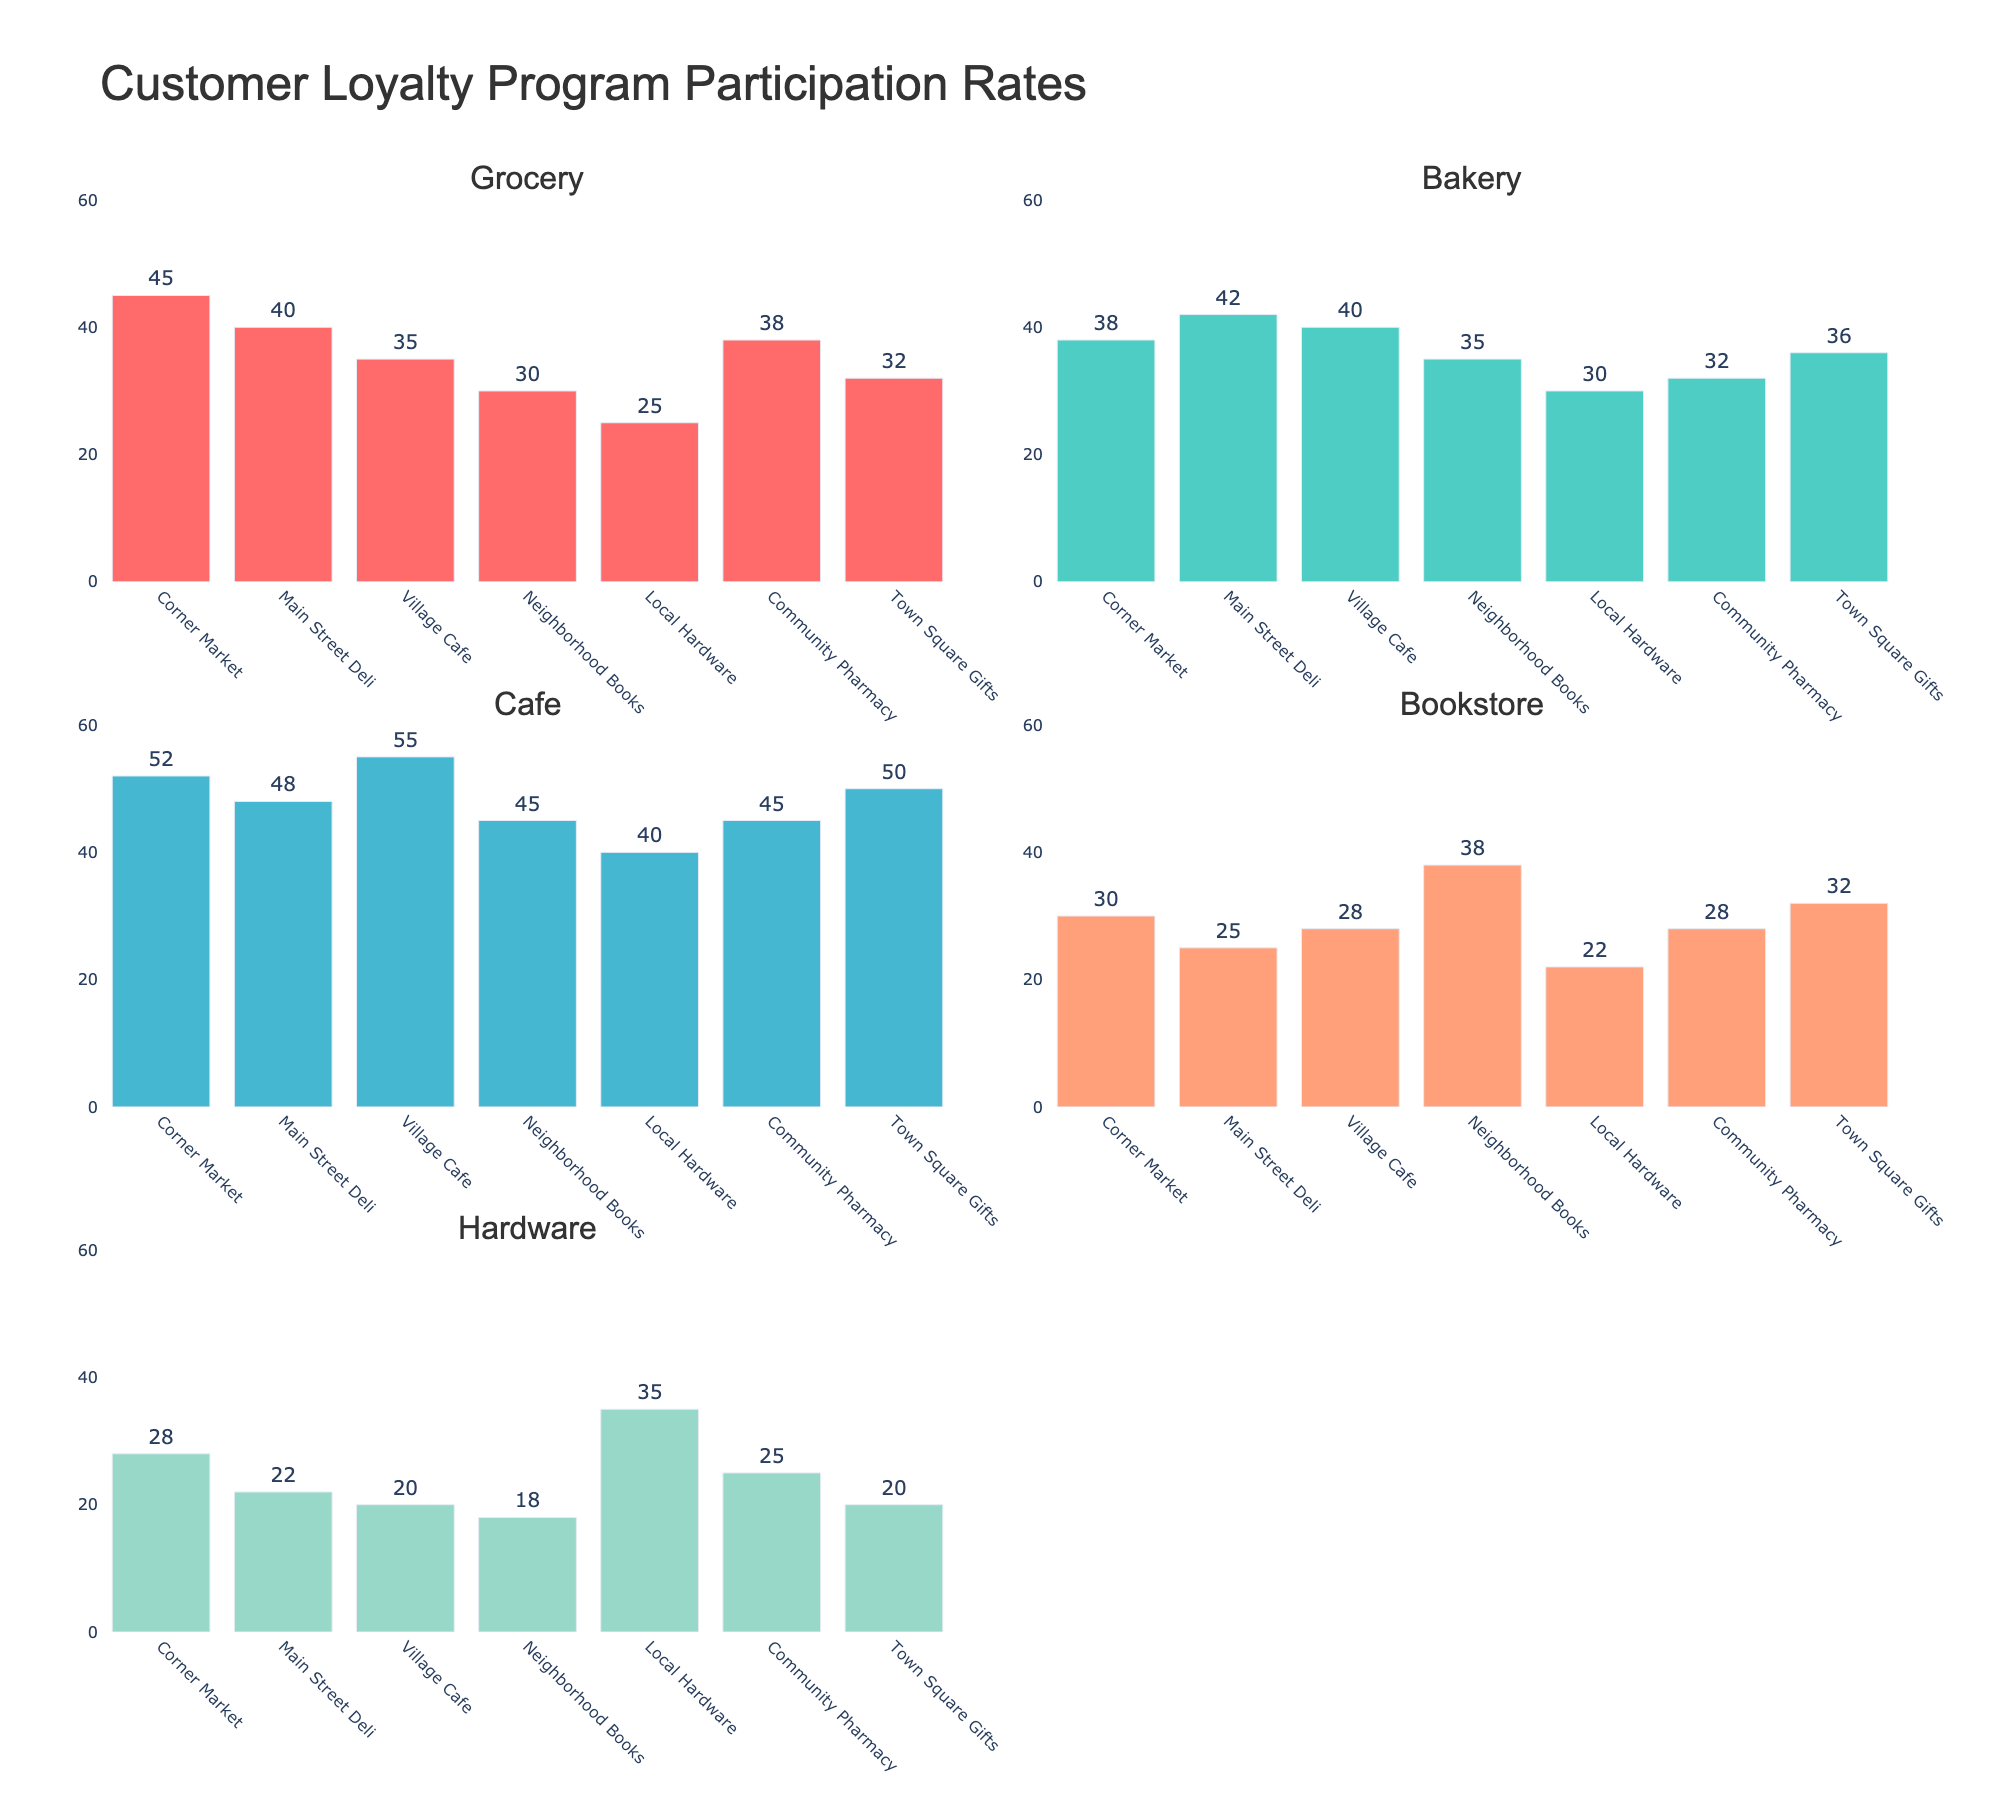What's the title of the figure? The title is displayed at the top center of the figure in a larger font size.
Answer: Customer Loyalty Program Participation Rates How many shop categories are compared in the figure? By counting the number of subplot titles, we can see there are 5 categories listed: Grocery, Bakery, Cafe, Bookstore, and Hardware.
Answer: 5 Which shop has the highest participation rate in the Cafe category? In the subplot for Cafe, the highest bar represents the Village Cafe, with a rate of 55%.
Answer: Village Cafe What is the participation rate for Main Street Deli in the Bakery category? Locate the bar corresponding to Main Street Deli in the Bakery subplot. The label shows a rate of 42%.
Answer: 42% Compare the Grocery participation rates of Corner Market and Local Hardware. Which is higher, and by how much? Corner Market has 45%, while Local Hardware has 25% in the Grocery category. Subtracting these gives the difference.
Answer: Corner Market is higher by 20% Which shop category has the least participation for Community Pharmacy? By locating Community Pharmacy's bars across all subplots, we find that the lowest bar is in the Hardware category, at 25%.
Answer: Hardware What is the average participation rate for all shops in the Bookstore category? Sum up the participation rates: 30, 25, 28, 38, 22, 32 = 175. Divide by the number of shops, 6, to get the average.
Answer: 29.17% Between Neighborhood Books and Town Square Gifts, which shop has a higher rate in the Grocery category? Refer to the Grocery subplot, compare the heights of the bars for Neighborhood Books (30%) and Town Square Gifts (32%).
Answer: Town Square Gifts What is the total participation rate for Corner Market across all categories? Add Corner Market's rates across all subplots: 45 + 38 + 52 + 30 + 28 = 193.
Answer: 193% In which category does Local Hardware have the highest participation rate? Look at the Local Hardware's bars across all subplots and find the highest one. It’s in the Hardware category at 35%.
Answer: Hardware 